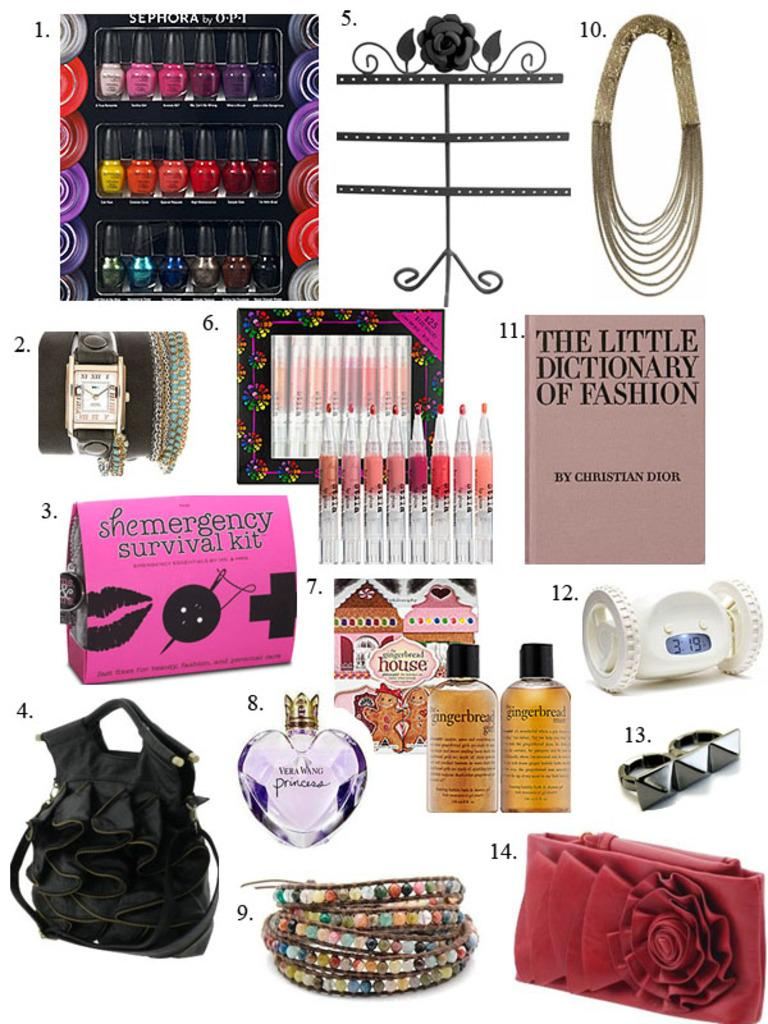<image>
Present a compact description of the photo's key features. a book that has The Little Dictionary of Fashion on it 